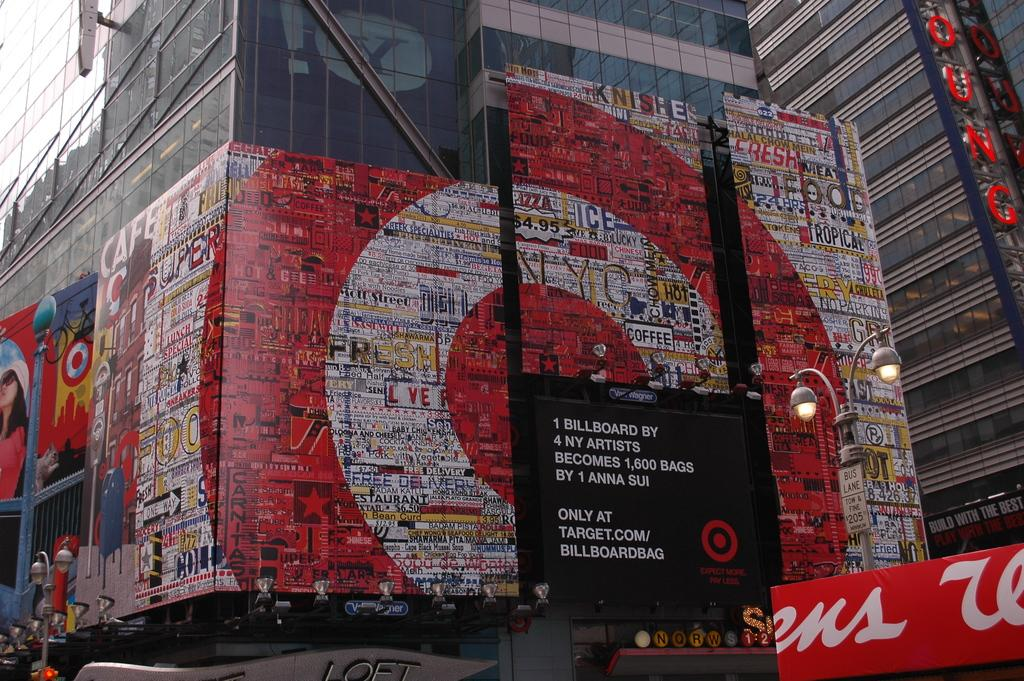<image>
Write a terse but informative summary of the picture. A mural that makes a target with one word being Fresh. 